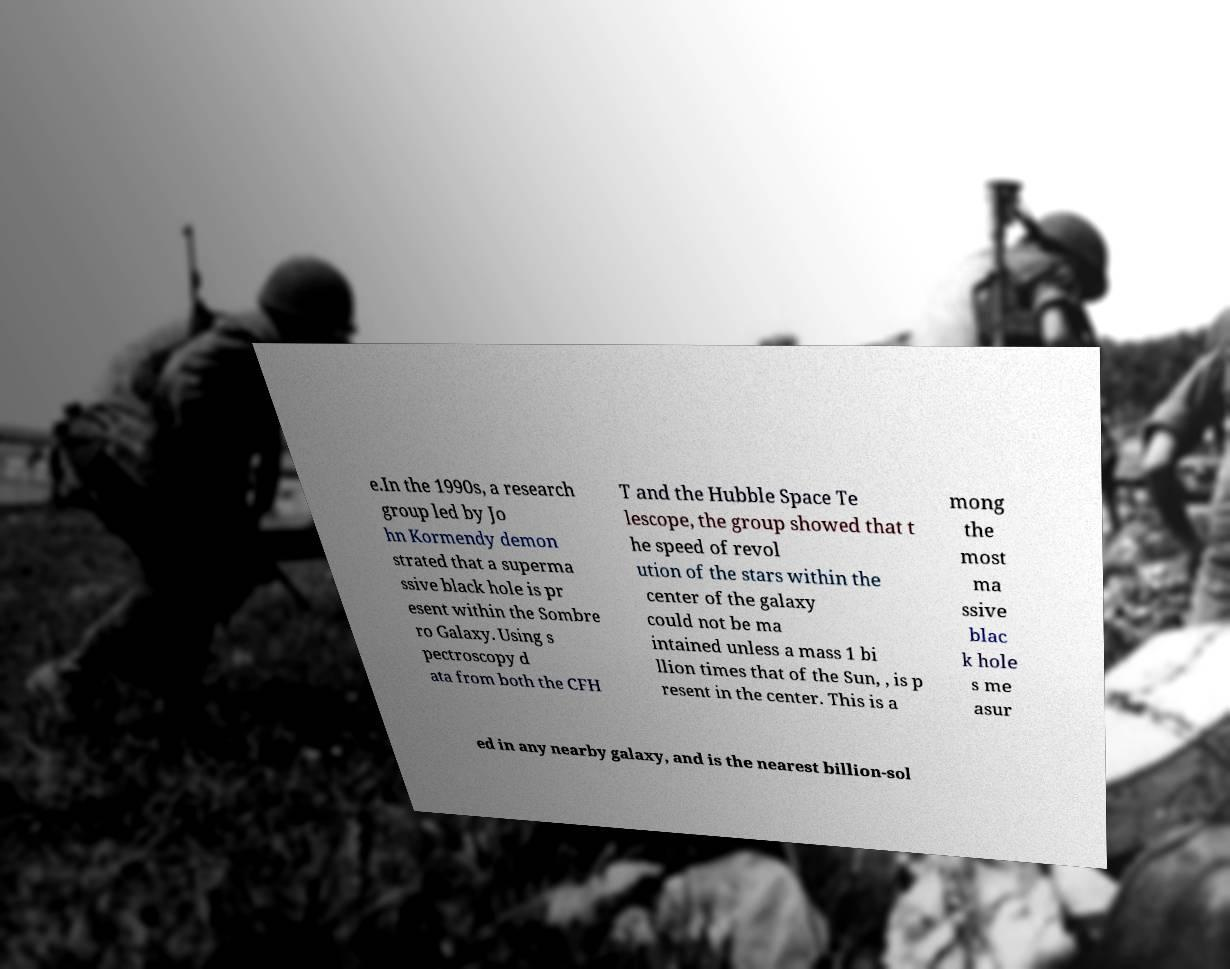Can you accurately transcribe the text from the provided image for me? e.In the 1990s, a research group led by Jo hn Kormendy demon strated that a superma ssive black hole is pr esent within the Sombre ro Galaxy. Using s pectroscopy d ata from both the CFH T and the Hubble Space Te lescope, the group showed that t he speed of revol ution of the stars within the center of the galaxy could not be ma intained unless a mass 1 bi llion times that of the Sun, , is p resent in the center. This is a mong the most ma ssive blac k hole s me asur ed in any nearby galaxy, and is the nearest billion-sol 